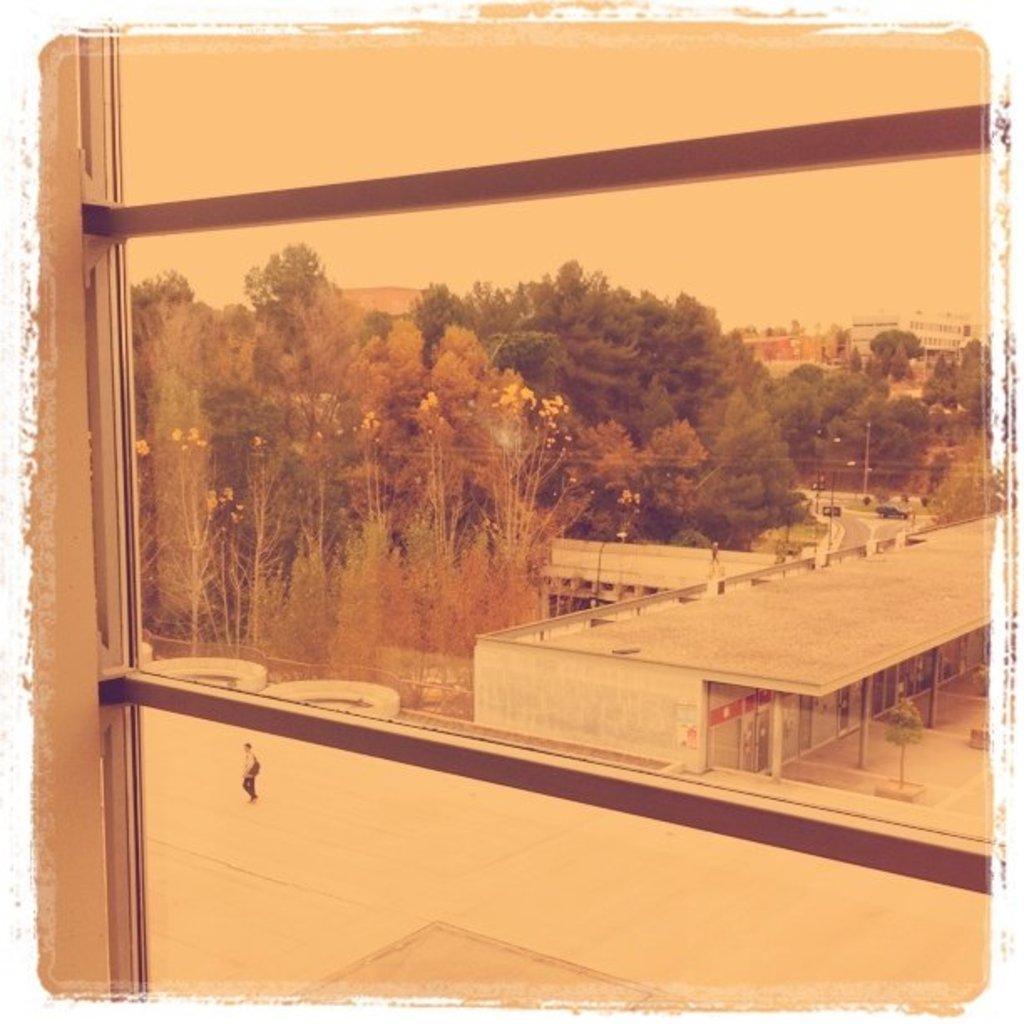How would you summarize this image in a sentence or two? In this picture we can see view from the glass. Behind we can see the small boy walking in the ground. In the background there is a shed and some trees. 